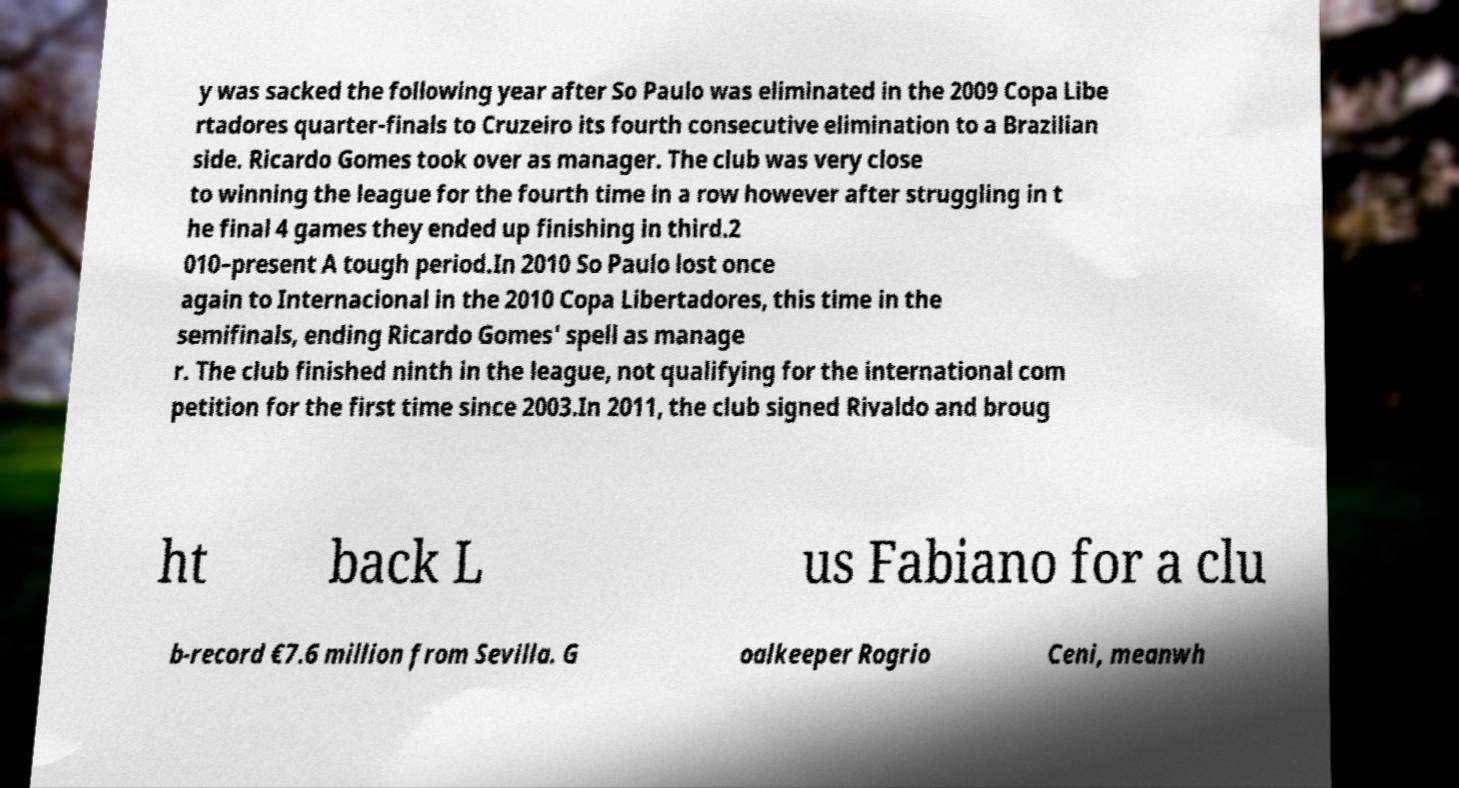What messages or text are displayed in this image? I need them in a readable, typed format. y was sacked the following year after So Paulo was eliminated in the 2009 Copa Libe rtadores quarter-finals to Cruzeiro its fourth consecutive elimination to a Brazilian side. Ricardo Gomes took over as manager. The club was very close to winning the league for the fourth time in a row however after struggling in t he final 4 games they ended up finishing in third.2 010–present A tough period.In 2010 So Paulo lost once again to Internacional in the 2010 Copa Libertadores, this time in the semifinals, ending Ricardo Gomes' spell as manage r. The club finished ninth in the league, not qualifying for the international com petition for the first time since 2003.In 2011, the club signed Rivaldo and broug ht back L us Fabiano for a clu b-record €7.6 million from Sevilla. G oalkeeper Rogrio Ceni, meanwh 